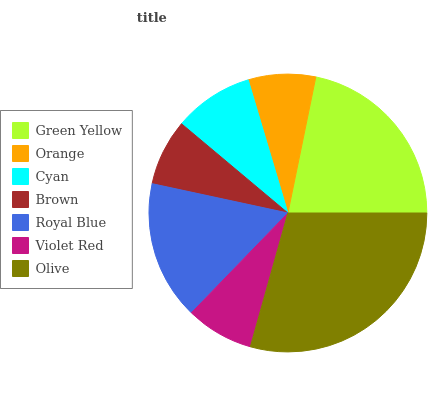Is Brown the minimum?
Answer yes or no. Yes. Is Olive the maximum?
Answer yes or no. Yes. Is Orange the minimum?
Answer yes or no. No. Is Orange the maximum?
Answer yes or no. No. Is Green Yellow greater than Orange?
Answer yes or no. Yes. Is Orange less than Green Yellow?
Answer yes or no. Yes. Is Orange greater than Green Yellow?
Answer yes or no. No. Is Green Yellow less than Orange?
Answer yes or no. No. Is Cyan the high median?
Answer yes or no. Yes. Is Cyan the low median?
Answer yes or no. Yes. Is Royal Blue the high median?
Answer yes or no. No. Is Brown the low median?
Answer yes or no. No. 